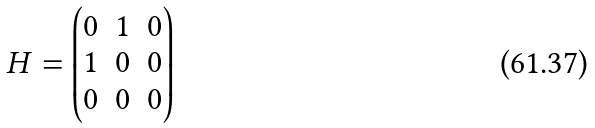Convert formula to latex. <formula><loc_0><loc_0><loc_500><loc_500>H = \begin{pmatrix} 0 & 1 & 0 \\ 1 & 0 & 0 \\ 0 & 0 & 0 \end{pmatrix}</formula> 